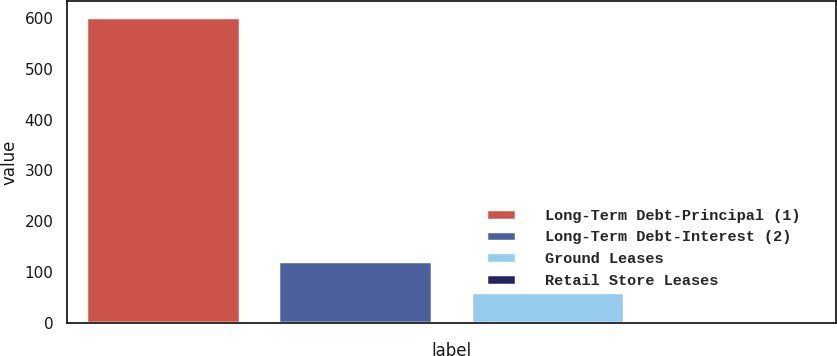Convert chart. <chart><loc_0><loc_0><loc_500><loc_500><bar_chart><fcel>Long-Term Debt-Principal (1)<fcel>Long-Term Debt-Interest (2)<fcel>Ground Leases<fcel>Retail Store Leases<nl><fcel>602.2<fcel>121.32<fcel>61.21<fcel>1.1<nl></chart> 